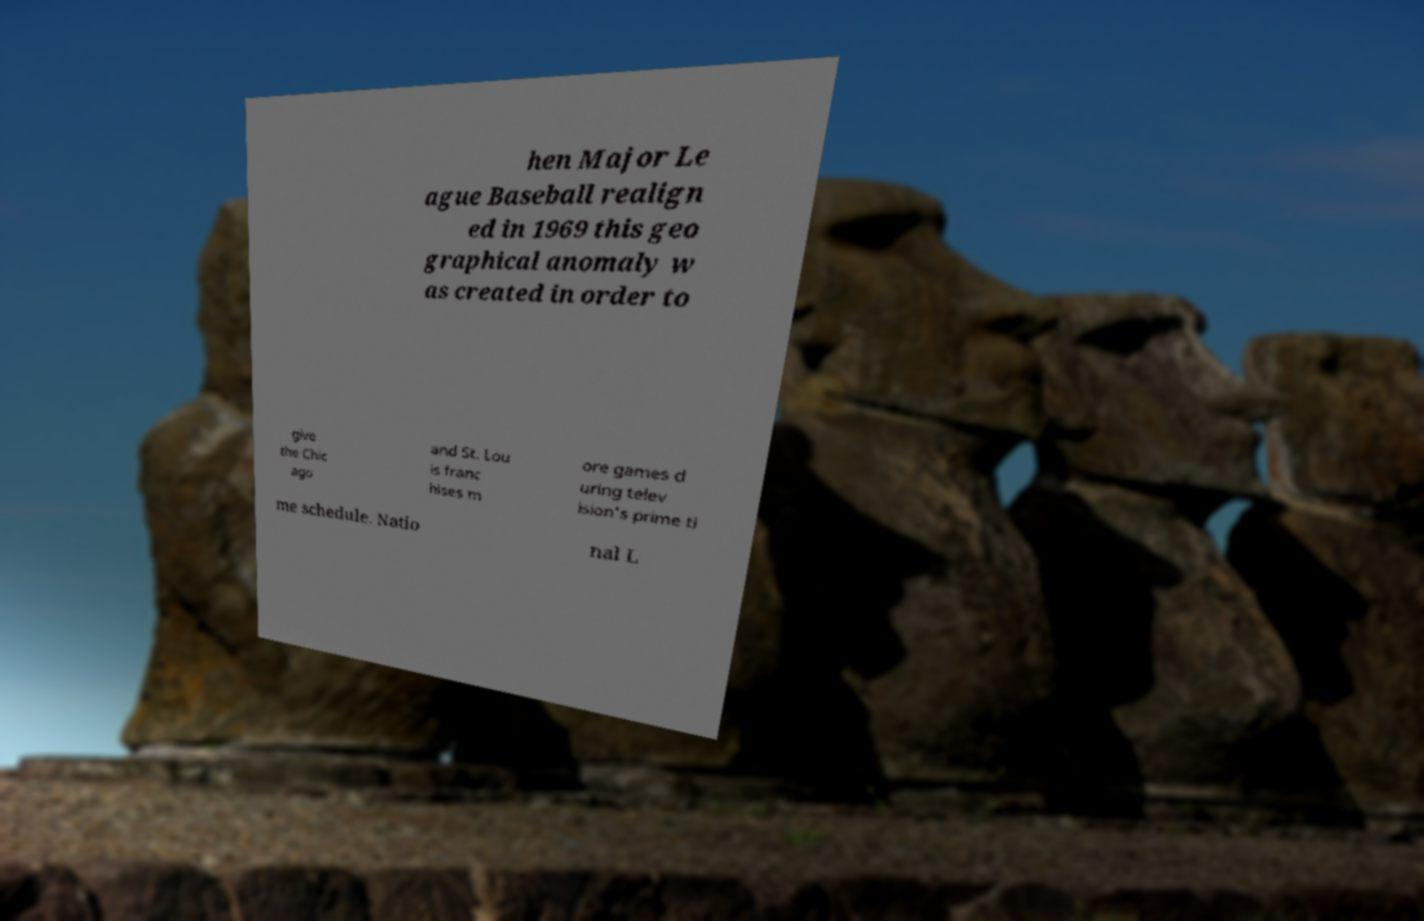For documentation purposes, I need the text within this image transcribed. Could you provide that? hen Major Le ague Baseball realign ed in 1969 this geo graphical anomaly w as created in order to give the Chic ago and St. Lou is franc hises m ore games d uring telev ision's prime ti me schedule. Natio nal L 